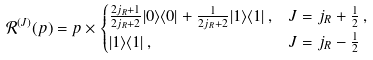<formula> <loc_0><loc_0><loc_500><loc_500>\mathcal { R } ^ { ( J ) } ( p ) & = p \times \begin{cases} \frac { 2 j _ { R } + 1 } { 2 j _ { R } + 2 } | 0 \rangle \langle 0 | + \frac { 1 } { 2 j _ { R } + 2 } | 1 \rangle \langle 1 | \, , & J = j _ { R } + \frac { 1 } { 2 } \, , \\ | 1 \rangle \langle 1 | \, , & J = j _ { R } - \frac { 1 } { 2 } \end{cases}</formula> 